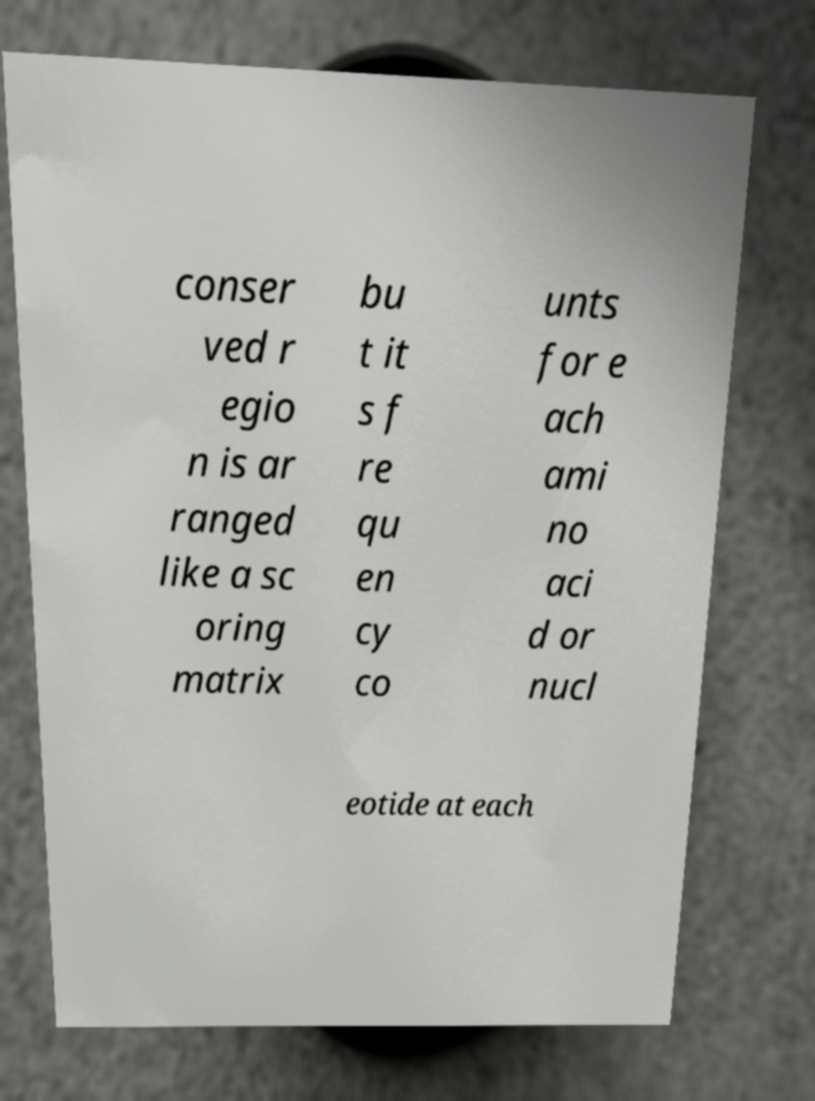Can you accurately transcribe the text from the provided image for me? conser ved r egio n is ar ranged like a sc oring matrix bu t it s f re qu en cy co unts for e ach ami no aci d or nucl eotide at each 